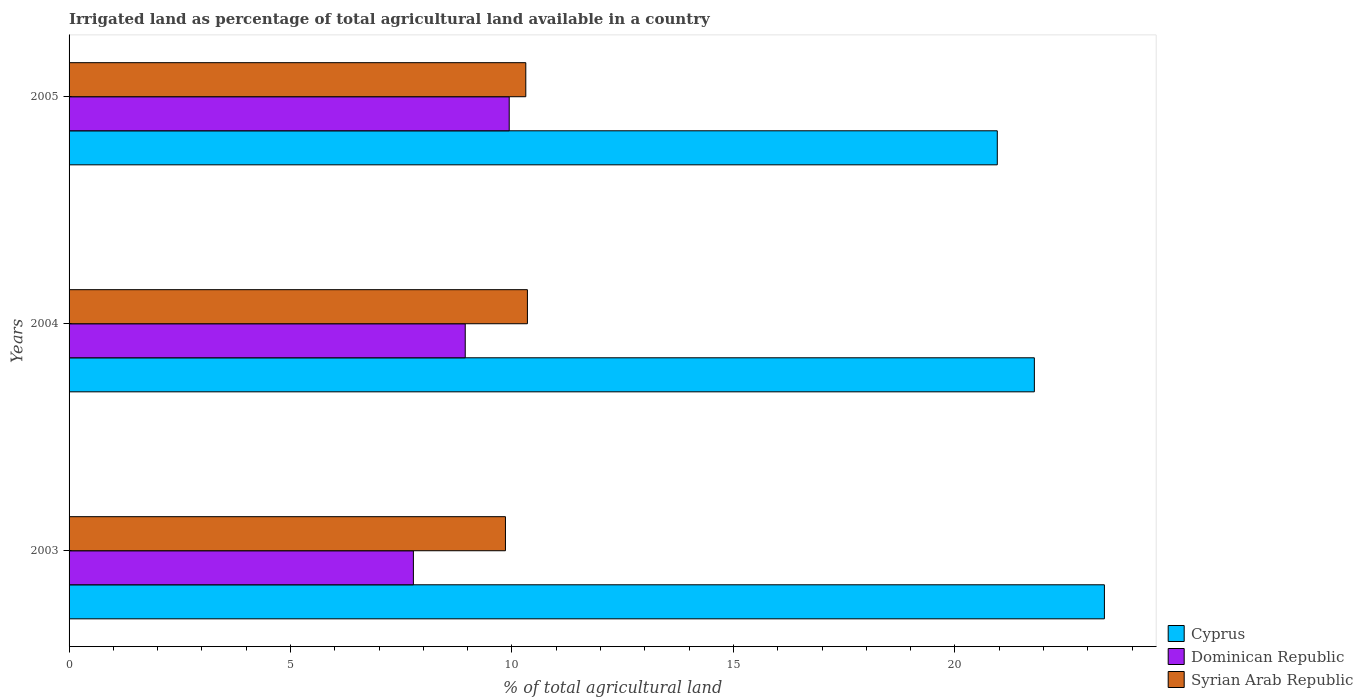How many different coloured bars are there?
Your response must be concise. 3. Are the number of bars per tick equal to the number of legend labels?
Your answer should be compact. Yes. Are the number of bars on each tick of the Y-axis equal?
Ensure brevity in your answer.  Yes. What is the percentage of irrigated land in Dominican Republic in 2004?
Your answer should be compact. 8.94. Across all years, what is the maximum percentage of irrigated land in Dominican Republic?
Ensure brevity in your answer.  9.94. Across all years, what is the minimum percentage of irrigated land in Syrian Arab Republic?
Your answer should be compact. 9.85. In which year was the percentage of irrigated land in Cyprus maximum?
Provide a succinct answer. 2003. In which year was the percentage of irrigated land in Dominican Republic minimum?
Offer a terse response. 2003. What is the total percentage of irrigated land in Syrian Arab Republic in the graph?
Offer a terse response. 30.51. What is the difference between the percentage of irrigated land in Syrian Arab Republic in 2004 and that in 2005?
Your answer should be very brief. 0.04. What is the difference between the percentage of irrigated land in Dominican Republic in 2005 and the percentage of irrigated land in Cyprus in 2003?
Keep it short and to the point. -13.44. What is the average percentage of irrigated land in Dominican Republic per year?
Provide a short and direct response. 8.89. In the year 2005, what is the difference between the percentage of irrigated land in Dominican Republic and percentage of irrigated land in Syrian Arab Republic?
Your response must be concise. -0.37. What is the ratio of the percentage of irrigated land in Syrian Arab Republic in 2004 to that in 2005?
Provide a short and direct response. 1. Is the percentage of irrigated land in Syrian Arab Republic in 2004 less than that in 2005?
Provide a short and direct response. No. What is the difference between the highest and the second highest percentage of irrigated land in Cyprus?
Offer a terse response. 1.58. What is the difference between the highest and the lowest percentage of irrigated land in Dominican Republic?
Provide a short and direct response. 2.16. Is the sum of the percentage of irrigated land in Dominican Republic in 2003 and 2005 greater than the maximum percentage of irrigated land in Syrian Arab Republic across all years?
Offer a terse response. Yes. What does the 3rd bar from the top in 2005 represents?
Make the answer very short. Cyprus. What does the 2nd bar from the bottom in 2005 represents?
Your answer should be very brief. Dominican Republic. How many years are there in the graph?
Provide a short and direct response. 3. Are the values on the major ticks of X-axis written in scientific E-notation?
Provide a succinct answer. No. Does the graph contain any zero values?
Offer a terse response. No. Does the graph contain grids?
Provide a succinct answer. No. How many legend labels are there?
Provide a succinct answer. 3. How are the legend labels stacked?
Offer a terse response. Vertical. What is the title of the graph?
Offer a terse response. Irrigated land as percentage of total agricultural land available in a country. Does "San Marino" appear as one of the legend labels in the graph?
Offer a very short reply. No. What is the label or title of the X-axis?
Offer a very short reply. % of total agricultural land. What is the % of total agricultural land of Cyprus in 2003?
Your answer should be compact. 23.38. What is the % of total agricultural land of Dominican Republic in 2003?
Ensure brevity in your answer.  7.77. What is the % of total agricultural land in Syrian Arab Republic in 2003?
Your answer should be compact. 9.85. What is the % of total agricultural land in Cyprus in 2004?
Your answer should be very brief. 21.79. What is the % of total agricultural land of Dominican Republic in 2004?
Your response must be concise. 8.94. What is the % of total agricultural land in Syrian Arab Republic in 2004?
Your answer should be compact. 10.35. What is the % of total agricultural land in Cyprus in 2005?
Offer a very short reply. 20.96. What is the % of total agricultural land of Dominican Republic in 2005?
Your answer should be compact. 9.94. What is the % of total agricultural land in Syrian Arab Republic in 2005?
Your answer should be very brief. 10.31. Across all years, what is the maximum % of total agricultural land of Cyprus?
Make the answer very short. 23.38. Across all years, what is the maximum % of total agricultural land of Dominican Republic?
Offer a very short reply. 9.94. Across all years, what is the maximum % of total agricultural land in Syrian Arab Republic?
Provide a succinct answer. 10.35. Across all years, what is the minimum % of total agricultural land of Cyprus?
Offer a very short reply. 20.96. Across all years, what is the minimum % of total agricultural land in Dominican Republic?
Offer a very short reply. 7.77. Across all years, what is the minimum % of total agricultural land in Syrian Arab Republic?
Provide a succinct answer. 9.85. What is the total % of total agricultural land of Cyprus in the graph?
Your response must be concise. 66.13. What is the total % of total agricultural land of Dominican Republic in the graph?
Offer a terse response. 26.66. What is the total % of total agricultural land in Syrian Arab Republic in the graph?
Make the answer very short. 30.51. What is the difference between the % of total agricultural land in Cyprus in 2003 and that in 2004?
Provide a succinct answer. 1.58. What is the difference between the % of total agricultural land of Dominican Republic in 2003 and that in 2004?
Ensure brevity in your answer.  -1.17. What is the difference between the % of total agricultural land in Syrian Arab Republic in 2003 and that in 2004?
Your answer should be very brief. -0.5. What is the difference between the % of total agricultural land of Cyprus in 2003 and that in 2005?
Give a very brief answer. 2.42. What is the difference between the % of total agricultural land of Dominican Republic in 2003 and that in 2005?
Your response must be concise. -2.16. What is the difference between the % of total agricultural land of Syrian Arab Republic in 2003 and that in 2005?
Provide a succinct answer. -0.46. What is the difference between the % of total agricultural land of Cyprus in 2004 and that in 2005?
Offer a terse response. 0.84. What is the difference between the % of total agricultural land of Dominican Republic in 2004 and that in 2005?
Keep it short and to the point. -0.99. What is the difference between the % of total agricultural land in Syrian Arab Republic in 2004 and that in 2005?
Your response must be concise. 0.04. What is the difference between the % of total agricultural land in Cyprus in 2003 and the % of total agricultural land in Dominican Republic in 2004?
Give a very brief answer. 14.43. What is the difference between the % of total agricultural land of Cyprus in 2003 and the % of total agricultural land of Syrian Arab Republic in 2004?
Offer a very short reply. 13.03. What is the difference between the % of total agricultural land in Dominican Republic in 2003 and the % of total agricultural land in Syrian Arab Republic in 2004?
Provide a short and direct response. -2.57. What is the difference between the % of total agricultural land of Cyprus in 2003 and the % of total agricultural land of Dominican Republic in 2005?
Give a very brief answer. 13.44. What is the difference between the % of total agricultural land in Cyprus in 2003 and the % of total agricultural land in Syrian Arab Republic in 2005?
Give a very brief answer. 13.06. What is the difference between the % of total agricultural land in Dominican Republic in 2003 and the % of total agricultural land in Syrian Arab Republic in 2005?
Provide a succinct answer. -2.54. What is the difference between the % of total agricultural land of Cyprus in 2004 and the % of total agricultural land of Dominican Republic in 2005?
Keep it short and to the point. 11.86. What is the difference between the % of total agricultural land in Cyprus in 2004 and the % of total agricultural land in Syrian Arab Republic in 2005?
Keep it short and to the point. 11.48. What is the difference between the % of total agricultural land of Dominican Republic in 2004 and the % of total agricultural land of Syrian Arab Republic in 2005?
Your answer should be very brief. -1.37. What is the average % of total agricultural land of Cyprus per year?
Your answer should be very brief. 22.04. What is the average % of total agricultural land of Dominican Republic per year?
Your answer should be compact. 8.89. What is the average % of total agricultural land in Syrian Arab Republic per year?
Keep it short and to the point. 10.17. In the year 2003, what is the difference between the % of total agricultural land in Cyprus and % of total agricultural land in Dominican Republic?
Keep it short and to the point. 15.6. In the year 2003, what is the difference between the % of total agricultural land in Cyprus and % of total agricultural land in Syrian Arab Republic?
Give a very brief answer. 13.52. In the year 2003, what is the difference between the % of total agricultural land of Dominican Republic and % of total agricultural land of Syrian Arab Republic?
Keep it short and to the point. -2.08. In the year 2004, what is the difference between the % of total agricultural land of Cyprus and % of total agricultural land of Dominican Republic?
Your answer should be very brief. 12.85. In the year 2004, what is the difference between the % of total agricultural land of Cyprus and % of total agricultural land of Syrian Arab Republic?
Offer a very short reply. 11.45. In the year 2004, what is the difference between the % of total agricultural land of Dominican Republic and % of total agricultural land of Syrian Arab Republic?
Provide a short and direct response. -1.4. In the year 2005, what is the difference between the % of total agricultural land of Cyprus and % of total agricultural land of Dominican Republic?
Give a very brief answer. 11.02. In the year 2005, what is the difference between the % of total agricultural land in Cyprus and % of total agricultural land in Syrian Arab Republic?
Ensure brevity in your answer.  10.65. In the year 2005, what is the difference between the % of total agricultural land of Dominican Republic and % of total agricultural land of Syrian Arab Republic?
Make the answer very short. -0.37. What is the ratio of the % of total agricultural land in Cyprus in 2003 to that in 2004?
Ensure brevity in your answer.  1.07. What is the ratio of the % of total agricultural land of Dominican Republic in 2003 to that in 2004?
Your response must be concise. 0.87. What is the ratio of the % of total agricultural land of Syrian Arab Republic in 2003 to that in 2004?
Give a very brief answer. 0.95. What is the ratio of the % of total agricultural land in Cyprus in 2003 to that in 2005?
Offer a very short reply. 1.12. What is the ratio of the % of total agricultural land of Dominican Republic in 2003 to that in 2005?
Provide a short and direct response. 0.78. What is the ratio of the % of total agricultural land of Syrian Arab Republic in 2003 to that in 2005?
Your answer should be compact. 0.96. What is the ratio of the % of total agricultural land in Cyprus in 2004 to that in 2005?
Ensure brevity in your answer.  1.04. What is the ratio of the % of total agricultural land in Dominican Republic in 2004 to that in 2005?
Keep it short and to the point. 0.9. What is the ratio of the % of total agricultural land of Syrian Arab Republic in 2004 to that in 2005?
Offer a very short reply. 1. What is the difference between the highest and the second highest % of total agricultural land of Cyprus?
Your response must be concise. 1.58. What is the difference between the highest and the second highest % of total agricultural land in Syrian Arab Republic?
Provide a succinct answer. 0.04. What is the difference between the highest and the lowest % of total agricultural land of Cyprus?
Offer a terse response. 2.42. What is the difference between the highest and the lowest % of total agricultural land in Dominican Republic?
Provide a succinct answer. 2.16. What is the difference between the highest and the lowest % of total agricultural land of Syrian Arab Republic?
Make the answer very short. 0.5. 